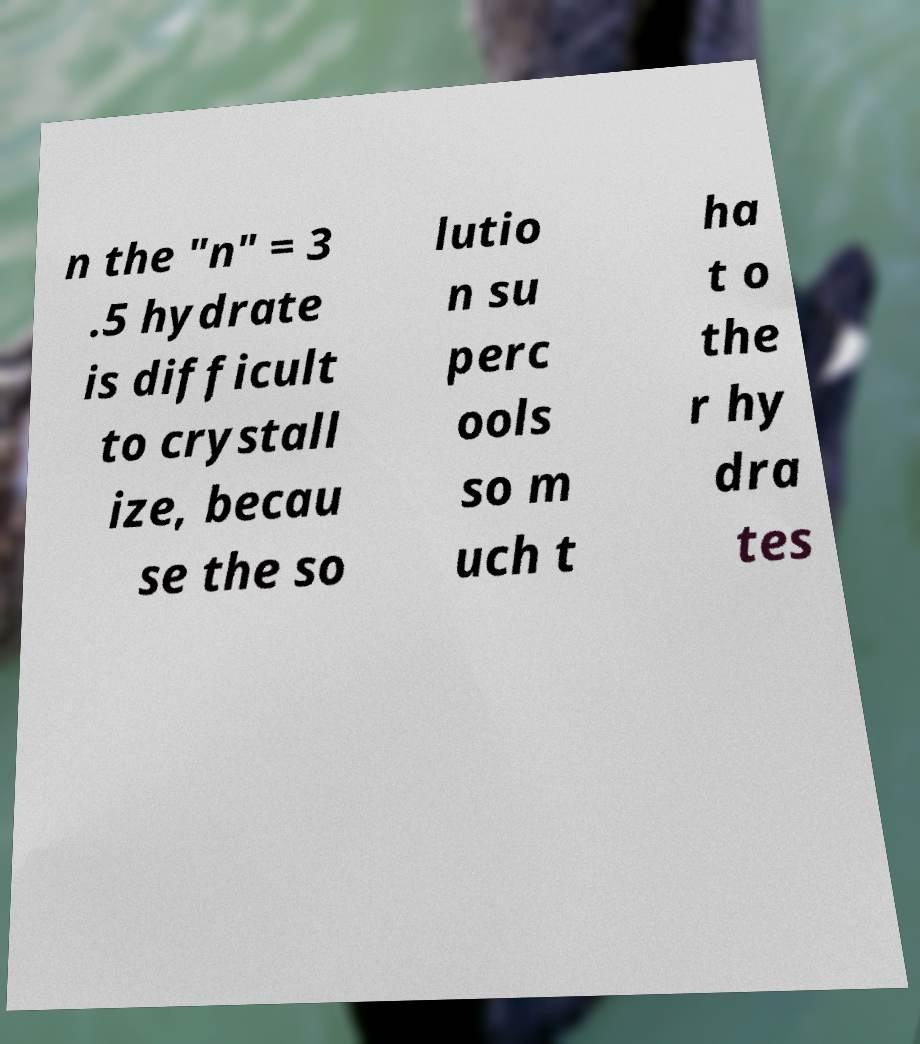Please read and relay the text visible in this image. What does it say? n the "n" = 3 .5 hydrate is difficult to crystall ize, becau se the so lutio n su perc ools so m uch t ha t o the r hy dra tes 